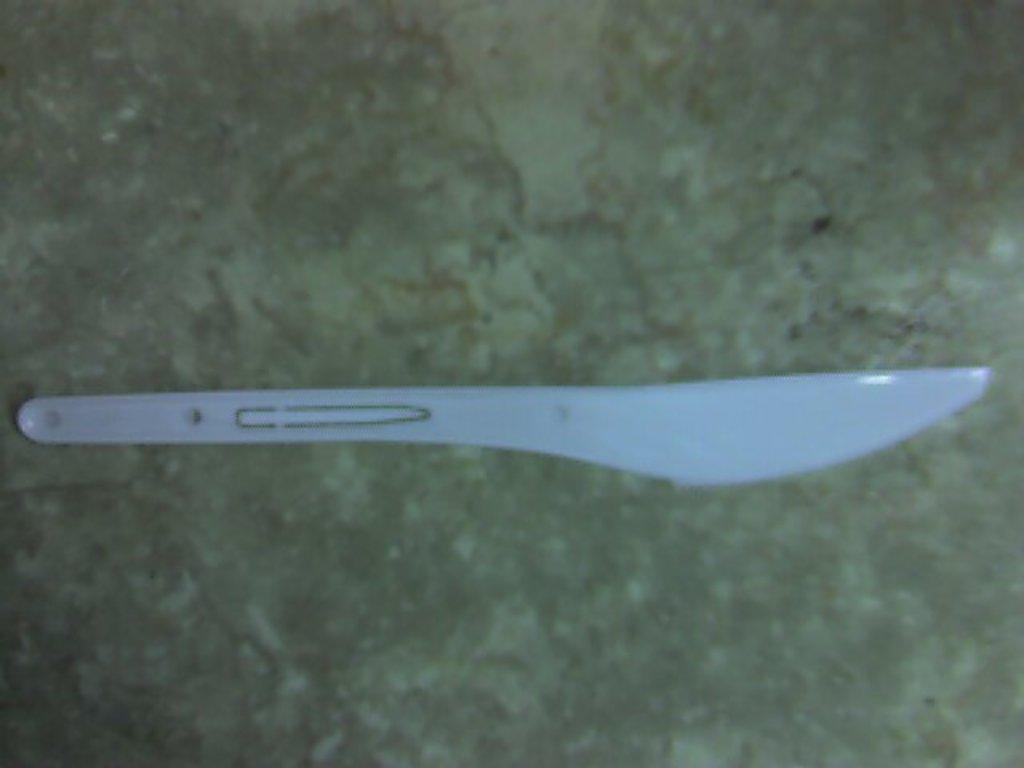What utensil is present in the image? There is a knife in the image. Can you tell me how many sisters are depicted in the image? There are no sisters present in the image; it only features a knife. What type of bee can be seen flying near the knife in the image? There is no bee present in the image; it only features a knife. 